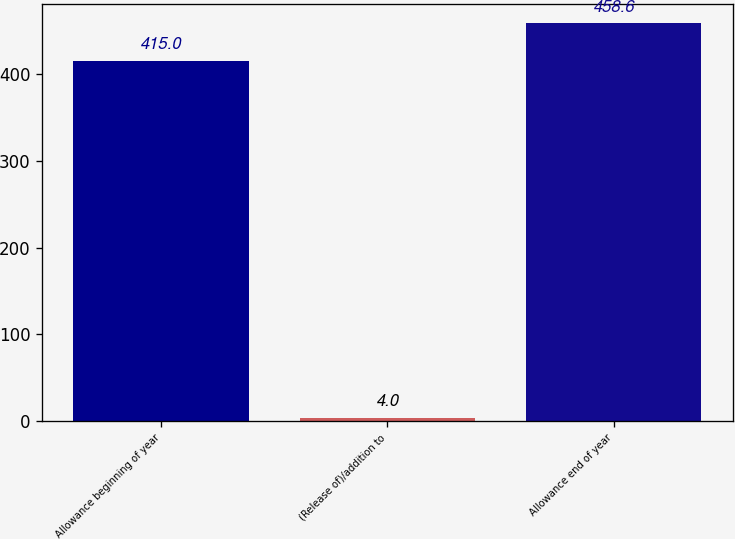<chart> <loc_0><loc_0><loc_500><loc_500><bar_chart><fcel>Allowance beginning of year<fcel>(Release of)/addition to<fcel>Allowance end of year<nl><fcel>415<fcel>4<fcel>458.6<nl></chart> 